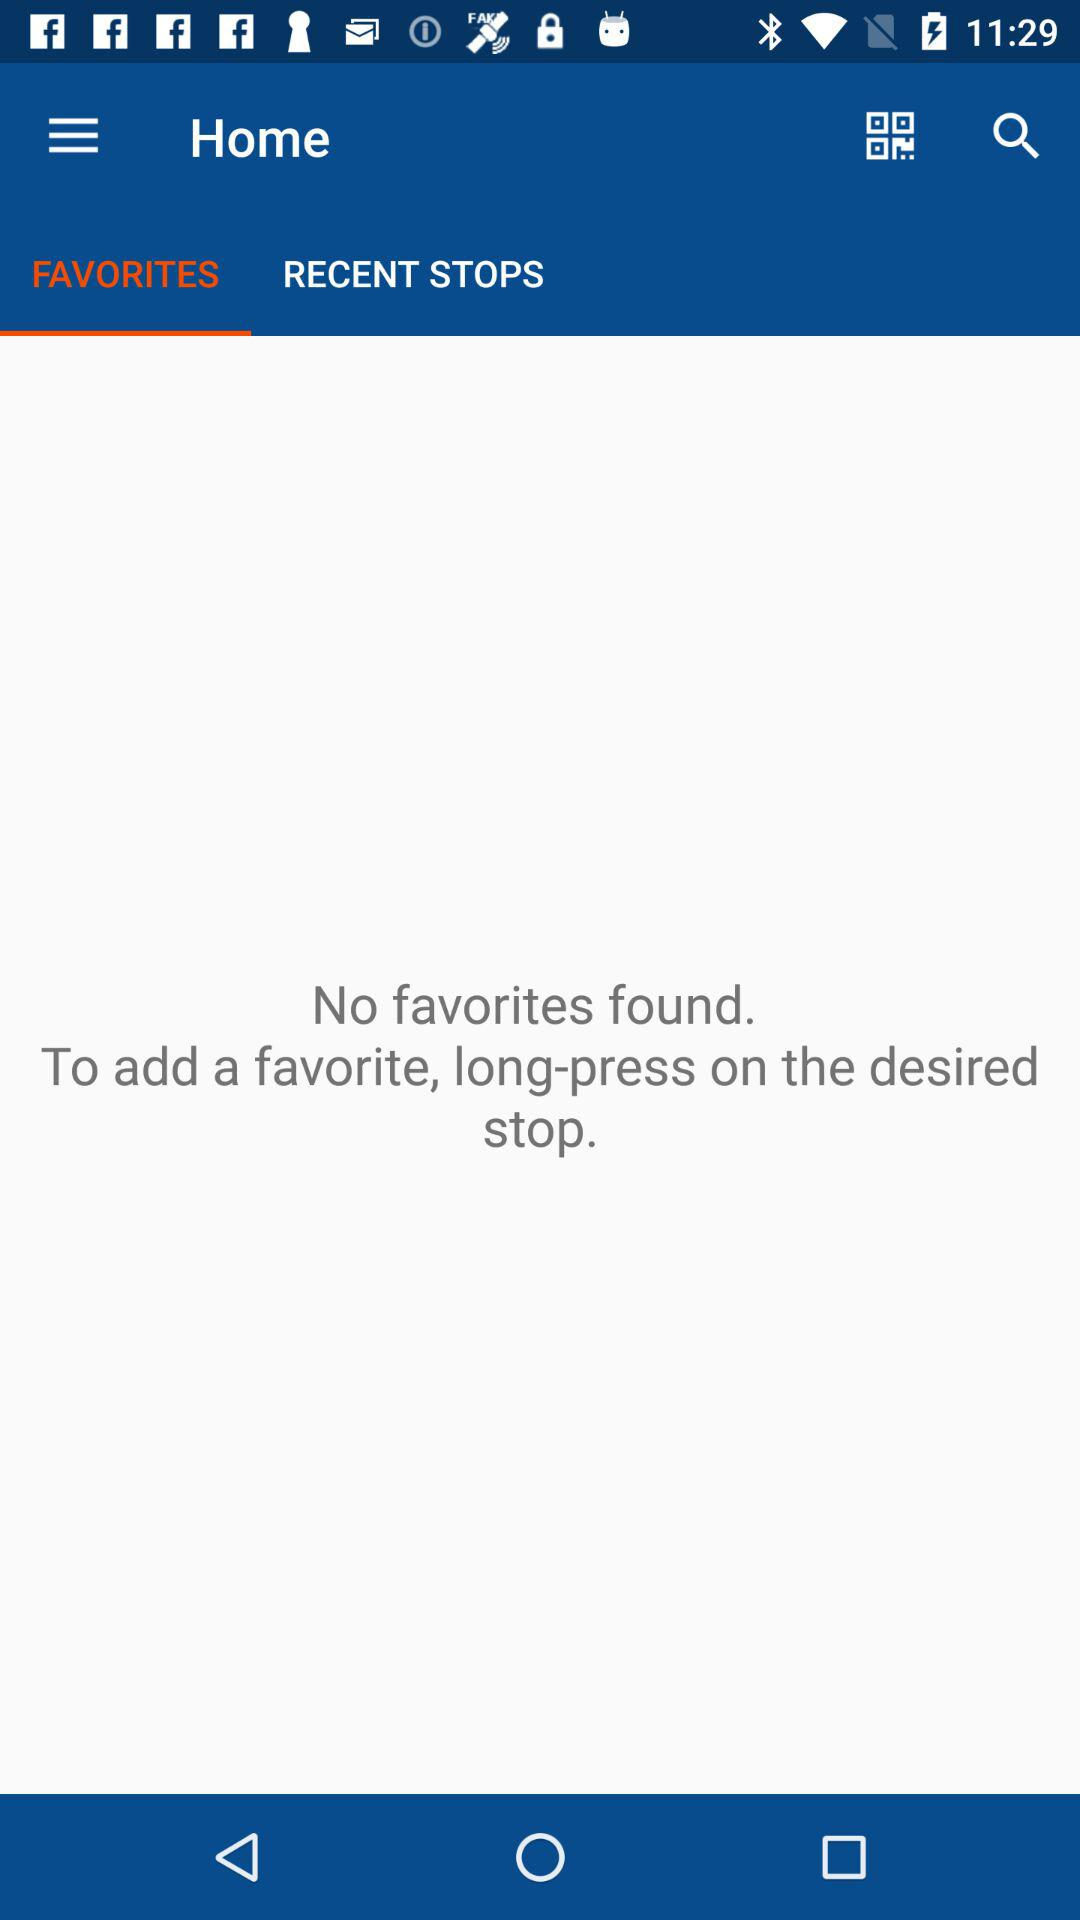What to do to add a favorite? To add a favorite, long-press on the desired stop. 